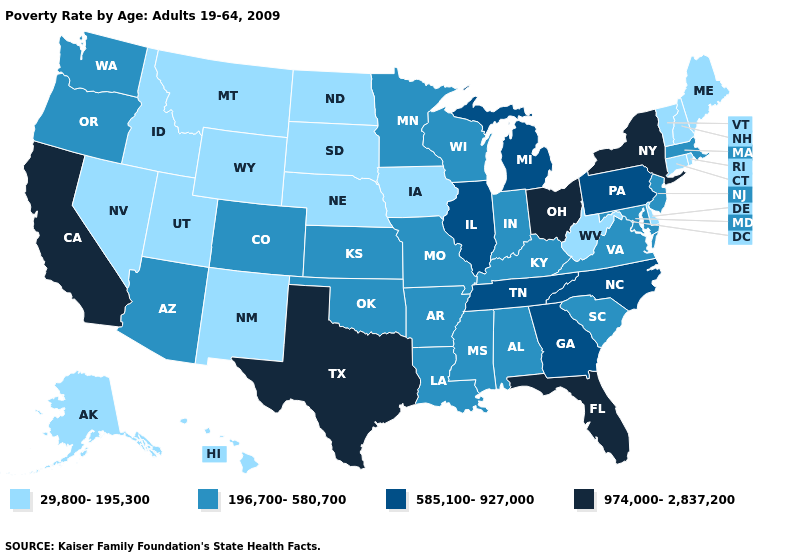Does Mississippi have the highest value in the South?
Short answer required. No. Among the states that border New Mexico , does Utah have the lowest value?
Quick response, please. Yes. Name the states that have a value in the range 585,100-927,000?
Give a very brief answer. Georgia, Illinois, Michigan, North Carolina, Pennsylvania, Tennessee. How many symbols are there in the legend?
Quick response, please. 4. Which states hav the highest value in the Northeast?
Quick response, please. New York. Name the states that have a value in the range 29,800-195,300?
Write a very short answer. Alaska, Connecticut, Delaware, Hawaii, Idaho, Iowa, Maine, Montana, Nebraska, Nevada, New Hampshire, New Mexico, North Dakota, Rhode Island, South Dakota, Utah, Vermont, West Virginia, Wyoming. What is the value of Mississippi?
Write a very short answer. 196,700-580,700. What is the value of Kansas?
Quick response, please. 196,700-580,700. Does Georgia have a lower value than North Carolina?
Concise answer only. No. Which states have the lowest value in the West?
Keep it brief. Alaska, Hawaii, Idaho, Montana, Nevada, New Mexico, Utah, Wyoming. What is the lowest value in states that border Nebraska?
Concise answer only. 29,800-195,300. Which states have the lowest value in the USA?
Be succinct. Alaska, Connecticut, Delaware, Hawaii, Idaho, Iowa, Maine, Montana, Nebraska, Nevada, New Hampshire, New Mexico, North Dakota, Rhode Island, South Dakota, Utah, Vermont, West Virginia, Wyoming. Name the states that have a value in the range 974,000-2,837,200?
Short answer required. California, Florida, New York, Ohio, Texas. What is the value of Nebraska?
Write a very short answer. 29,800-195,300. What is the highest value in the West ?
Answer briefly. 974,000-2,837,200. 